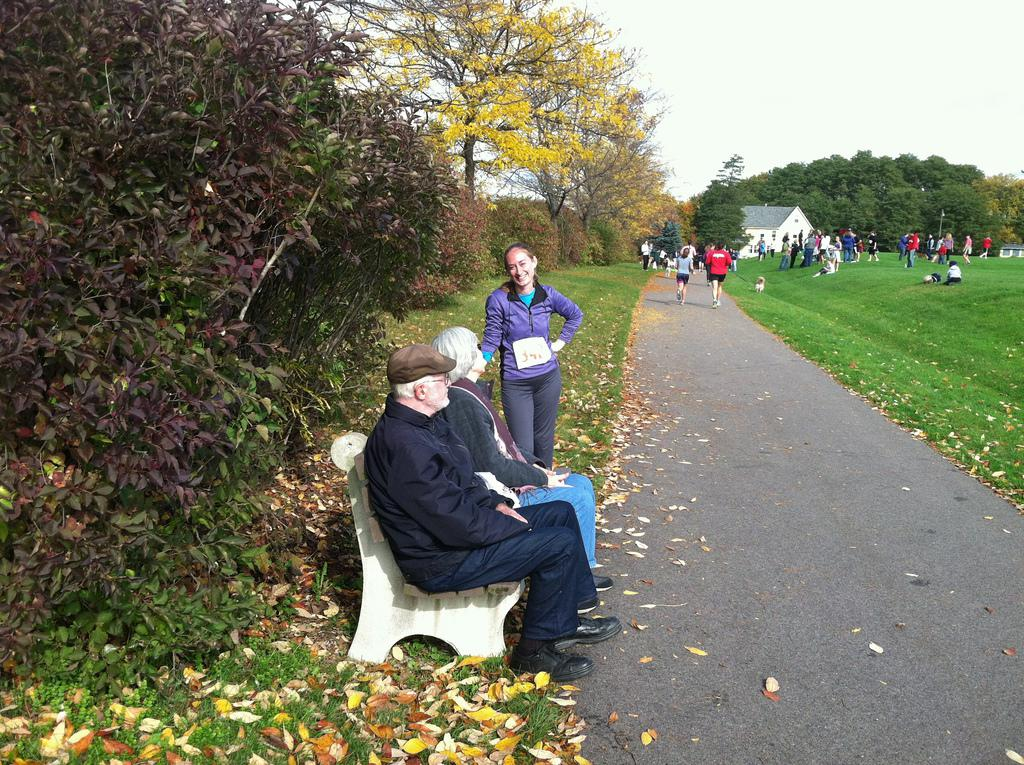Question: what is happening in this scene?
Choices:
A. It appears that a woman running a marathon has stopped to speak to two elderly woman on a white bench.
B. An elderly couple is sitting on a park bench.
C. A car is being stopped by a policeman.
D. Horses and galloping down a beach.
Answer with the letter. Answer: A Question: why does it appear to be fall?
Choices:
A. The trees are void of leaves.
B. Because the leaves have already changed color.
C. Multi colored leaves are in piles on the ground.
D. There are children wearing Halloween costumes.
Answer with the letter. Answer: B Question: what are the people sitting on?
Choices:
A. A chair.
B. A couch.
C. The scafolding.
D. A bench.
Answer with the letter. Answer: D Question: where is the bench located?
Choices:
A. In the hallway.
B. Next to a walkway.
C. Around the corner.
D. Outside the building.
Answer with the letter. Answer: B Question: when is the picture taken?
Choices:
A. At the party last night.
B. Last year.
C. On christmas.
D. During the day.
Answer with the letter. Answer: D Question: who is sitting on the bench?
Choices:
A. A cat.
B. Two men.
C. A man and a woman.
D. A woman.
Answer with the letter. Answer: C Question: who is standing next to the bench?
Choices:
A. Two men.
B. A woman.
C. A cat.
D. A kid.
Answer with the letter. Answer: B Question: what color cap does the man wear?
Choices:
A. A white cap.
B. A black cap.
C. A blue cap.
D. A brown cap.
Answer with the letter. Answer: D Question: what color are some of the leaves?
Choices:
A. Green.
B. Red.
C. Yellow.
D. Orange.
Answer with the letter. Answer: C Question: what is happening with some of the trees?
Choices:
A. They are blooming.
B. The wind is blowing through the branches.
C. They are getting hit by lightning.
D. Losing their leaves.
Answer with the letter. Answer: D Question: what color is the building?
Choices:
A. Brown.
B. White.
C. Red.
D. Green.
Answer with the letter. Answer: B Question: where are the trees?
Choices:
A. In front of the water.
B. Behind the bench.
C. On the hill.
D. In the field.
Answer with the letter. Answer: B Question: who is wearing a purple jacket?
Choices:
A. The woman.
B. The band member.
C. The runner.
D. The coach.
Answer with the letter. Answer: C Question: who is talking to an elderly couple?
Choices:
A. A small child.
B. The other elderly couple.
C. A woman.
D. The man.
Answer with the letter. Answer: C Question: how does the grass look?
Choices:
A. Green.
B. Tall.
C. Brown.
D. Wet.
Answer with the letter. Answer: A Question: who is wearing a red shirt?
Choices:
A. A baseball player.
B. A skateboarder.
C. A runner in the distance.
D. A skiier.
Answer with the letter. Answer: C 